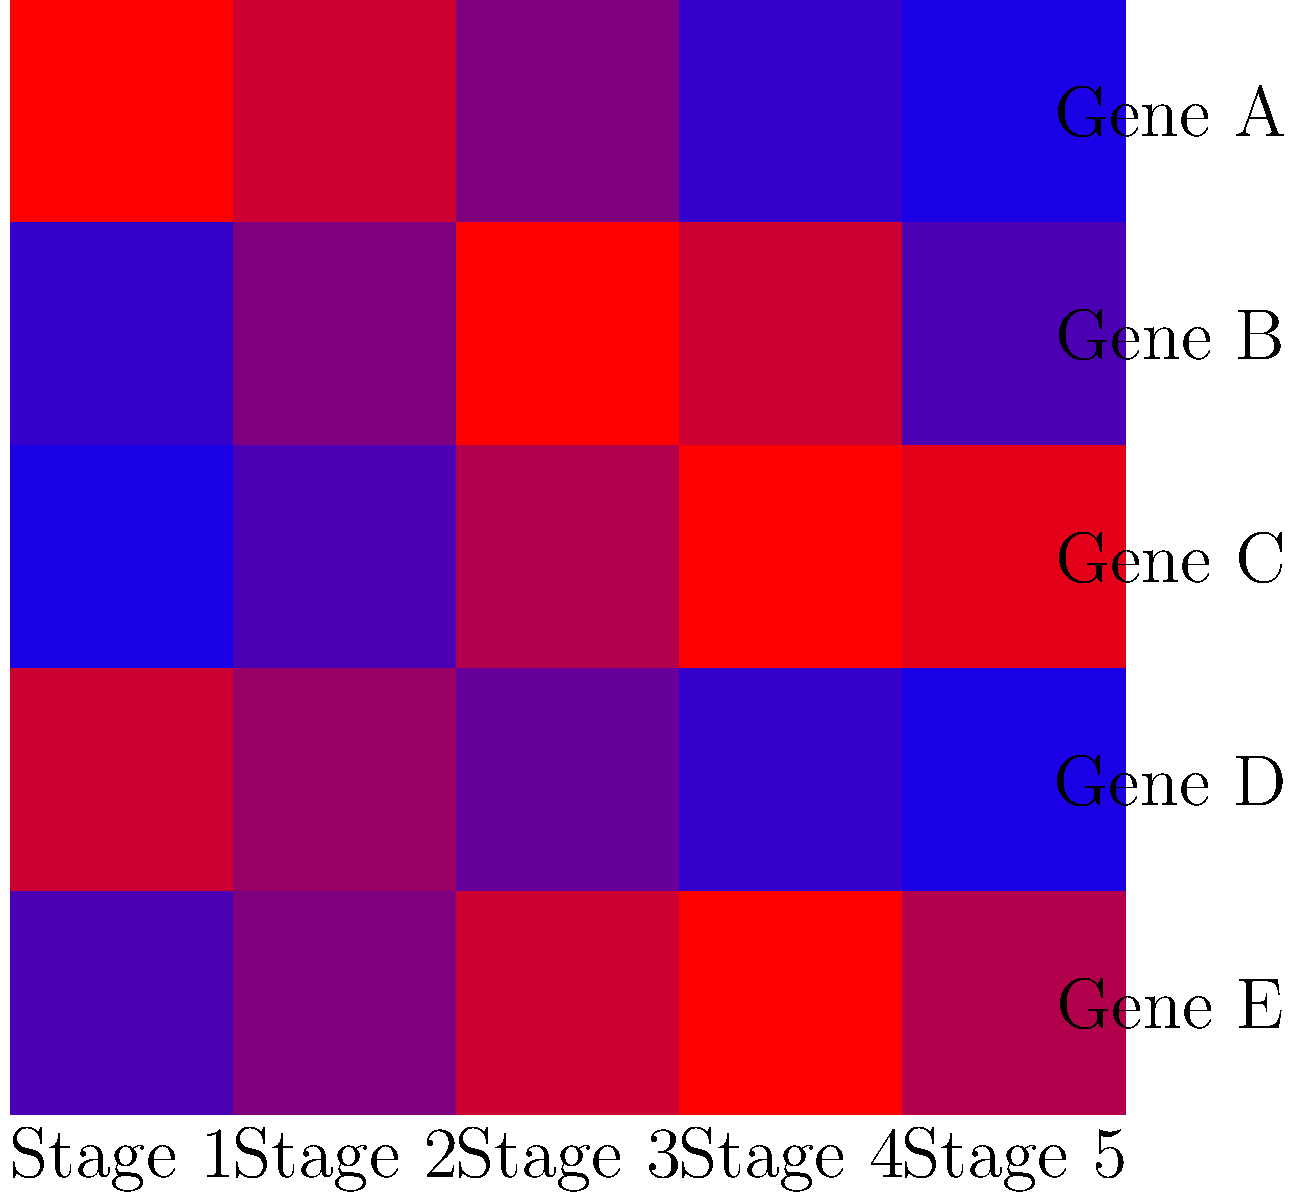Based on the gene expression heat map shown, which gene appears to have the highest expression level during the middle stages of disease progression? To answer this question, we need to analyze the heat map without relying on complex calculations. Let's break it down step-by-step:

1. Understand the heat map:
   - Each row represents a gene (A to E)
   - Each column represents a disease stage (1 to 5)
   - Blue color indicates low expression, while red indicates high expression

2. Focus on the middle stages:
   - The middle stages are approximately stages 2, 3, and 4

3. Scan each gene's expression pattern:
   - Gene A: Expression decreases across all stages
   - Gene B: Expression increases, peaks in the middle, then decreases
   - Gene C: Expression gradually increases, with high levels in later stages
   - Gene D: Expression decreases across all stages
   - Gene E: Expression increases, peaks in the middle, then slightly decreases

4. Identify the gene with the highest expression in the middle stages:
   - Gene B shows the most intense red color in the middle stages, particularly stage 3

5. Confirm the answer:
   - Gene B has the highest expression level during the middle stages of disease progression
Answer: Gene B 